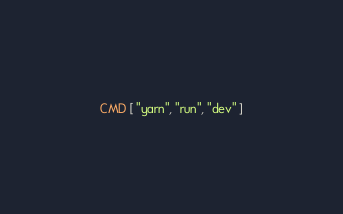<code> <loc_0><loc_0><loc_500><loc_500><_Dockerfile_>
CMD [ "yarn", "run", "dev" ]
</code> 